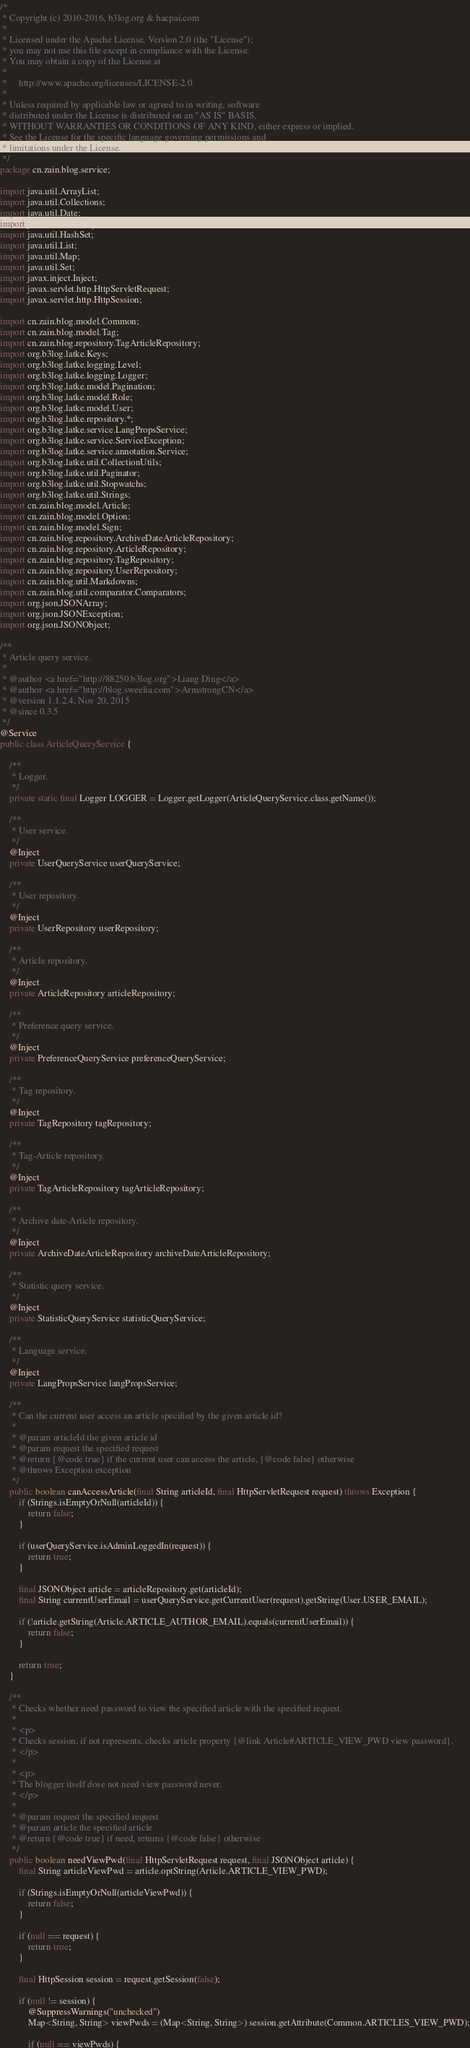Convert code to text. <code><loc_0><loc_0><loc_500><loc_500><_Java_>/*
 * Copyright (c) 2010-2016, b3log.org & hacpai.com
 *
 * Licensed under the Apache License, Version 2.0 (the "License");
 * you may not use this file except in compliance with the License.
 * You may obtain a copy of the License at
 *
 *     http://www.apache.org/licenses/LICENSE-2.0
 *
 * Unless required by applicable law or agreed to in writing, software
 * distributed under the License is distributed on an "AS IS" BASIS,
 * WITHOUT WARRANTIES OR CONDITIONS OF ANY KIND, either express or implied.
 * See the License for the specific language governing permissions and
 * limitations under the License.
 */
package cn.zain.blog.service;

import java.util.ArrayList;
import java.util.Collections;
import java.util.Date;
import java.util.HashMap;
import java.util.HashSet;
import java.util.List;
import java.util.Map;
import java.util.Set;
import javax.inject.Inject;
import javax.servlet.http.HttpServletRequest;
import javax.servlet.http.HttpSession;

import cn.zain.blog.model.Common;
import cn.zain.blog.model.Tag;
import cn.zain.blog.repository.TagArticleRepository;
import org.b3log.latke.Keys;
import org.b3log.latke.logging.Level;
import org.b3log.latke.logging.Logger;
import org.b3log.latke.model.Pagination;
import org.b3log.latke.model.Role;
import org.b3log.latke.model.User;
import org.b3log.latke.repository.*;
import org.b3log.latke.service.LangPropsService;
import org.b3log.latke.service.ServiceException;
import org.b3log.latke.service.annotation.Service;
import org.b3log.latke.util.CollectionUtils;
import org.b3log.latke.util.Paginator;
import org.b3log.latke.util.Stopwatchs;
import org.b3log.latke.util.Strings;
import cn.zain.blog.model.Article;
import cn.zain.blog.model.Option;
import cn.zain.blog.model.Sign;
import cn.zain.blog.repository.ArchiveDateArticleRepository;
import cn.zain.blog.repository.ArticleRepository;
import cn.zain.blog.repository.TagRepository;
import cn.zain.blog.repository.UserRepository;
import cn.zain.blog.util.Markdowns;
import cn.zain.blog.util.comparator.Comparators;
import org.json.JSONArray;
import org.json.JSONException;
import org.json.JSONObject;

/**
 * Article query service.
 *
 * @author <a href="http://88250.b3log.org">Liang Ding</a>
 * @author <a href="http://blog.sweelia.com">ArmstrongCN</a>
 * @version 1.1.2.4, Nov 20, 2015
 * @since 0.3.5
 */
@Service
public class ArticleQueryService {

    /**
     * Logger.
     */
    private static final Logger LOGGER = Logger.getLogger(ArticleQueryService.class.getName());

    /**
     * User service.
     */
    @Inject
    private UserQueryService userQueryService;

    /**
     * User repository.
     */
    @Inject
    private UserRepository userRepository;

    /**
     * Article repository.
     */
    @Inject
    private ArticleRepository articleRepository;

    /**
     * Preference query service.
     */
    @Inject
    private PreferenceQueryService preferenceQueryService;

    /**
     * Tag repository.
     */
    @Inject
    private TagRepository tagRepository;

    /**
     * Tag-Article repository.
     */
    @Inject
    private TagArticleRepository tagArticleRepository;

    /**
     * Archive date-Article repository.
     */
    @Inject
    private ArchiveDateArticleRepository archiveDateArticleRepository;

    /**
     * Statistic query service.
     */
    @Inject
    private StatisticQueryService statisticQueryService;

    /**
     * Language service.
     */
    @Inject
    private LangPropsService langPropsService;

    /**
     * Can the current user access an article specified by the given article id?
     *
     * @param articleId the given article id
     * @param request the specified request
     * @return {@code true} if the current user can access the article, {@code false} otherwise
     * @throws Exception exception
     */
    public boolean canAccessArticle(final String articleId, final HttpServletRequest request) throws Exception {
        if (Strings.isEmptyOrNull(articleId)) {
            return false;
        }

        if (userQueryService.isAdminLoggedIn(request)) {
            return true;
        }

        final JSONObject article = articleRepository.get(articleId);
        final String currentUserEmail = userQueryService.getCurrentUser(request).getString(User.USER_EMAIL);

        if (!article.getString(Article.ARTICLE_AUTHOR_EMAIL).equals(currentUserEmail)) {
            return false;
        }

        return true;
    }

    /**
     * Checks whether need password to view the specified article with the specified request.
     *
     * <p>
     * Checks session, if not represents, checks article property {@link Article#ARTICLE_VIEW_PWD view password}.
     * </p>
     *
     * <p>
     * The blogger itself dose not need view password never.
     * </p>
     *
     * @param request the specified request
     * @param article the specified article
     * @return {@code true} if need, returns {@code false} otherwise
     */
    public boolean needViewPwd(final HttpServletRequest request, final JSONObject article) {
        final String articleViewPwd = article.optString(Article.ARTICLE_VIEW_PWD);

        if (Strings.isEmptyOrNull(articleViewPwd)) {
            return false;
        }

        if (null == request) {
            return true;
        }

        final HttpSession session = request.getSession(false);

        if (null != session) {
            @SuppressWarnings("unchecked")
            Map<String, String> viewPwds = (Map<String, String>) session.getAttribute(Common.ARTICLES_VIEW_PWD);

            if (null == viewPwds) {</code> 